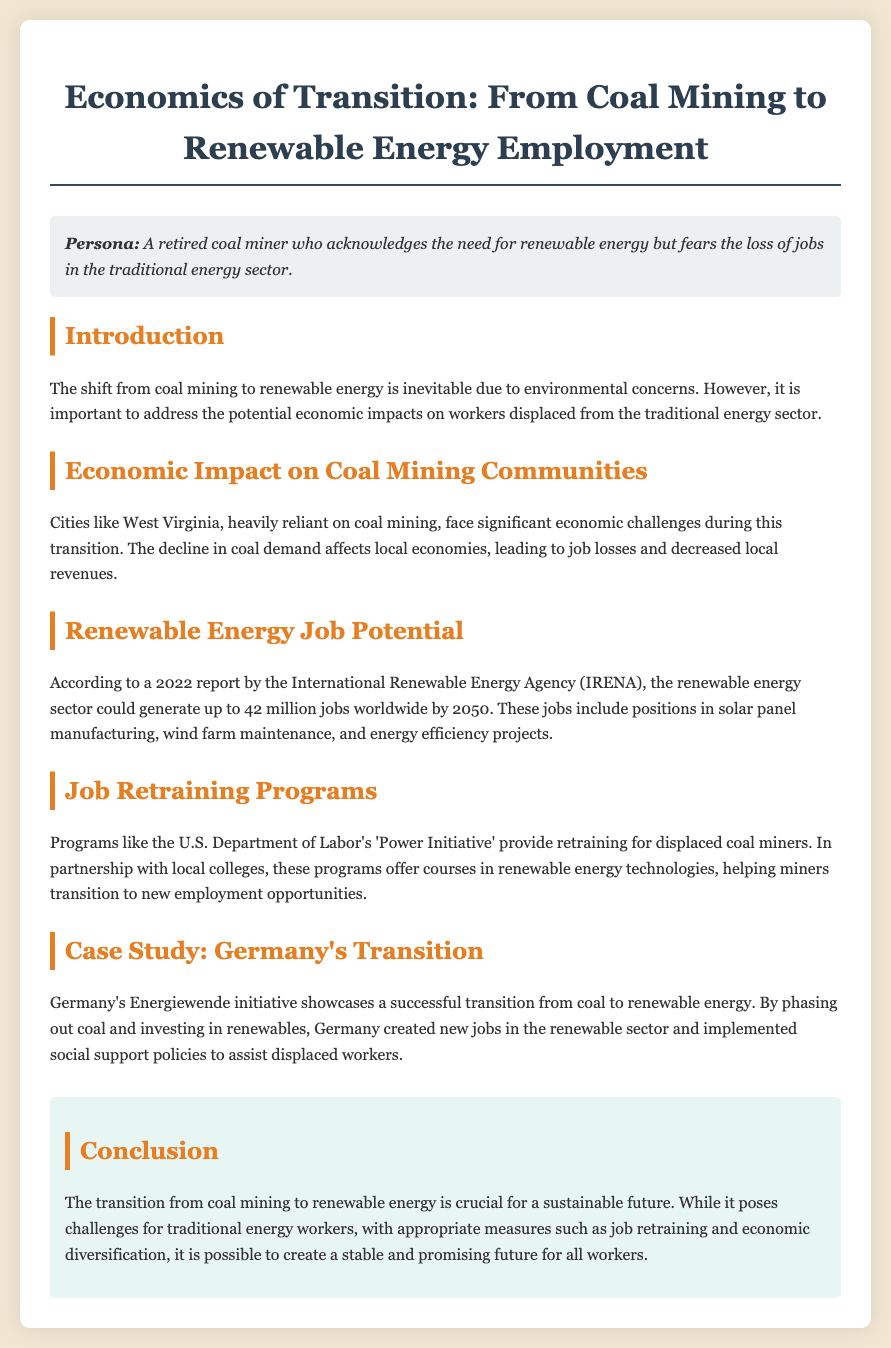what is the title of the document? The title is provided in the header section of the document as the main heading.
Answer: Economics of Transition: From Coal Mining to Renewable Energy Employment what organization reported on renewable energy job potential? The document mentions the International Renewable Energy Agency (IRENA) as the source of the report.
Answer: International Renewable Energy Agency (IRENA) how many jobs could the renewable energy sector generate by 2050? The document states the potential number of jobs that could be generated worldwide.
Answer: 42 million what initiative provides retraining for displaced coal miners? The document identifies a specific program aimed at helping miners transition to new jobs.
Answer: Power Initiative which country is used as a case study for a successful transition? The document highlights a country that implemented a successful energy transition example.
Answer: Germany what does the conclusion emphasize about the transition from coal to renewable energy? The conclusion outlines the importance of appropriate measures during the transition.
Answer: Economic diversification what local challenge do coal mining communities face during the transition? The document discusses specific economic challenges faced by areas dependent on coal mining.
Answer: Job losses and decreased local revenues what does Germany's Energiewende initiative focus on? The initiative in Germany aims to shift away from coal and towards renewable energy.
Answer: Phasing out coal and investing in renewables what type of programs does the U.S. Department of Labor provide? The document briefly describes the kind of programs being offered to support miners.
Answer: Retraining for displaced coal miners 